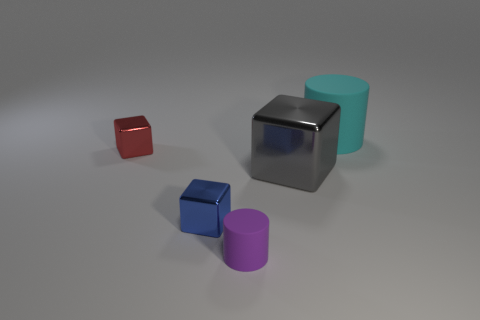Subtract all large blocks. How many blocks are left? 2 Add 1 tiny green metal cylinders. How many objects exist? 6 Subtract all blue blocks. How many blocks are left? 2 Subtract all gray shiny spheres. Subtract all tiny red shiny objects. How many objects are left? 4 Add 2 big cubes. How many big cubes are left? 3 Add 2 large gray shiny blocks. How many large gray shiny blocks exist? 3 Subtract 0 green spheres. How many objects are left? 5 Subtract all cubes. How many objects are left? 2 Subtract all yellow cylinders. Subtract all cyan spheres. How many cylinders are left? 2 